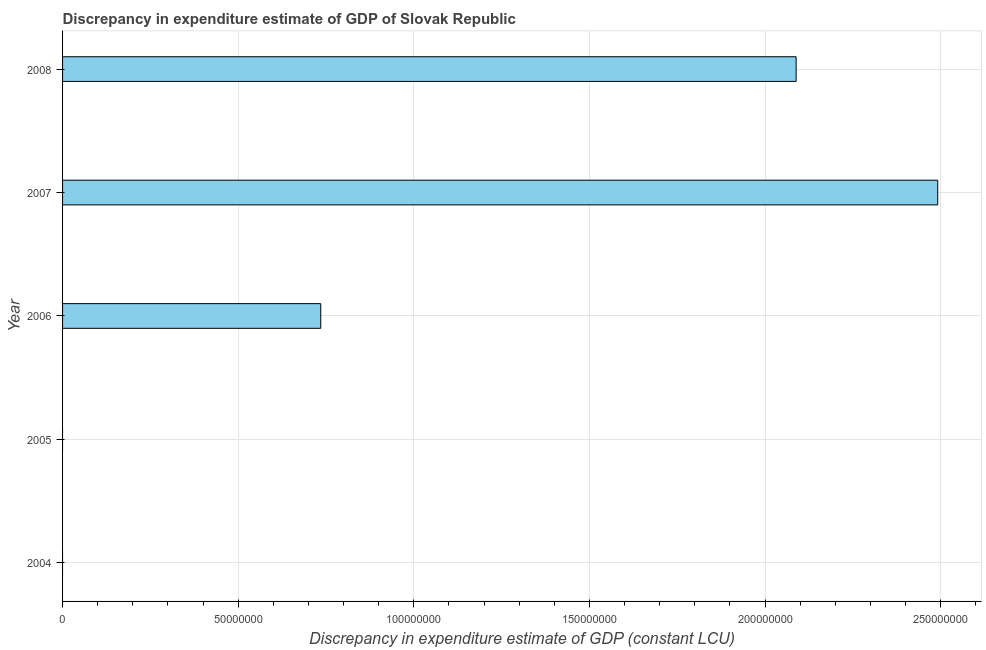Does the graph contain any zero values?
Ensure brevity in your answer.  Yes. What is the title of the graph?
Your response must be concise. Discrepancy in expenditure estimate of GDP of Slovak Republic. What is the label or title of the X-axis?
Ensure brevity in your answer.  Discrepancy in expenditure estimate of GDP (constant LCU). What is the label or title of the Y-axis?
Your answer should be compact. Year. What is the discrepancy in expenditure estimate of gdp in 2008?
Keep it short and to the point. 2.09e+08. Across all years, what is the maximum discrepancy in expenditure estimate of gdp?
Keep it short and to the point. 2.49e+08. What is the sum of the discrepancy in expenditure estimate of gdp?
Offer a very short reply. 5.32e+08. What is the difference between the discrepancy in expenditure estimate of gdp in 2006 and 2008?
Make the answer very short. -1.35e+08. What is the average discrepancy in expenditure estimate of gdp per year?
Your response must be concise. 1.06e+08. What is the median discrepancy in expenditure estimate of gdp?
Ensure brevity in your answer.  7.35e+07. In how many years, is the discrepancy in expenditure estimate of gdp greater than 110000000 LCU?
Provide a succinct answer. 2. What is the ratio of the discrepancy in expenditure estimate of gdp in 2006 to that in 2007?
Provide a succinct answer. 0.29. Is the discrepancy in expenditure estimate of gdp in 2006 less than that in 2007?
Ensure brevity in your answer.  Yes. What is the difference between the highest and the second highest discrepancy in expenditure estimate of gdp?
Offer a terse response. 4.03e+07. What is the difference between the highest and the lowest discrepancy in expenditure estimate of gdp?
Provide a short and direct response. 2.49e+08. How many bars are there?
Make the answer very short. 3. Are all the bars in the graph horizontal?
Offer a terse response. Yes. What is the difference between two consecutive major ticks on the X-axis?
Your response must be concise. 5.00e+07. What is the Discrepancy in expenditure estimate of GDP (constant LCU) in 2004?
Give a very brief answer. 0. What is the Discrepancy in expenditure estimate of GDP (constant LCU) in 2006?
Provide a succinct answer. 7.35e+07. What is the Discrepancy in expenditure estimate of GDP (constant LCU) in 2007?
Keep it short and to the point. 2.49e+08. What is the Discrepancy in expenditure estimate of GDP (constant LCU) of 2008?
Provide a succinct answer. 2.09e+08. What is the difference between the Discrepancy in expenditure estimate of GDP (constant LCU) in 2006 and 2007?
Make the answer very short. -1.76e+08. What is the difference between the Discrepancy in expenditure estimate of GDP (constant LCU) in 2006 and 2008?
Offer a terse response. -1.35e+08. What is the difference between the Discrepancy in expenditure estimate of GDP (constant LCU) in 2007 and 2008?
Your answer should be very brief. 4.03e+07. What is the ratio of the Discrepancy in expenditure estimate of GDP (constant LCU) in 2006 to that in 2007?
Ensure brevity in your answer.  0.29. What is the ratio of the Discrepancy in expenditure estimate of GDP (constant LCU) in 2006 to that in 2008?
Offer a terse response. 0.35. What is the ratio of the Discrepancy in expenditure estimate of GDP (constant LCU) in 2007 to that in 2008?
Your answer should be very brief. 1.19. 